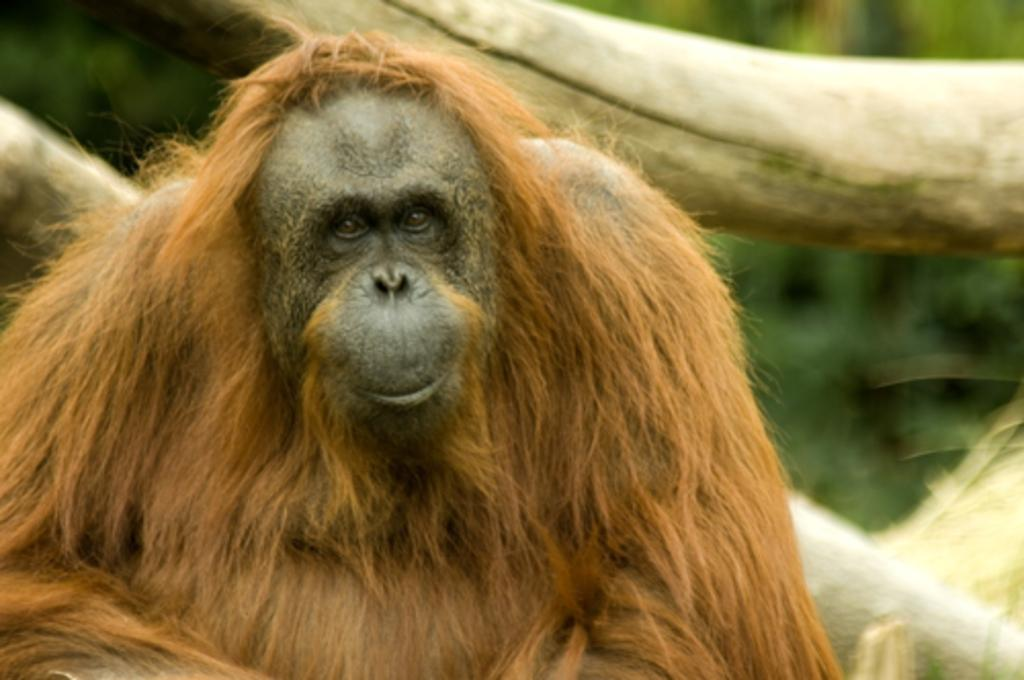What animal is in the foreground of the image? There is a chimpanzee in the foreground of the image. What can be seen behind the chimpanzee? There are trunks behind the chimpanzee. How would you describe the background of the image? The background of the image is blurred. What type of sugar is being crushed by the chimpanzee in the image? There is no sugar or crushing activity present in the image; it features a chimpanzee and trunks in the background. Where is the kettle located in the image? There is no kettle present in the image. 